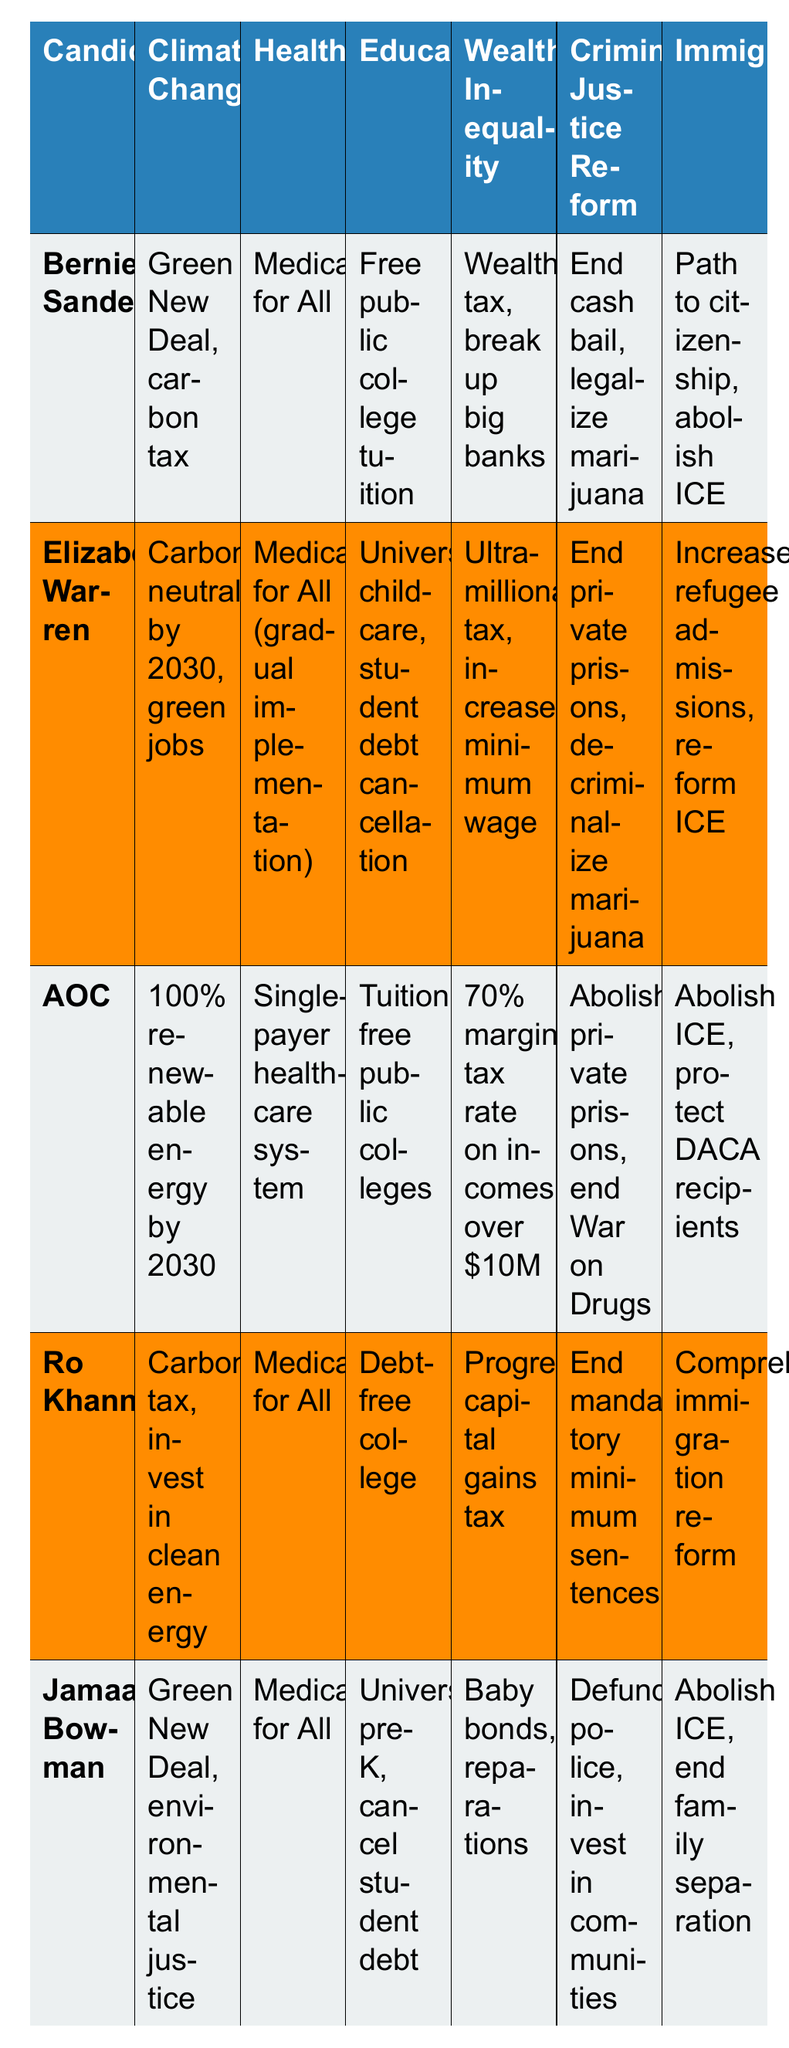What are Bernie Sanders' main stances on wealth inequality? According to the table, Bernie Sanders advocates for a wealth tax and breaking up big banks as his main positions on wealth inequality.
Answer: Wealth tax, break up big banks Which candidate advocates for a carbon-neutral environment by 2030? The table indicates that Elizabeth Warren's stance includes becoming carbon-neutral by 2030 and promoting green jobs.
Answer: Elizabeth Warren Is AOC's healthcare stance more progressive than Ro Khanna's? AOC proposes a single-payer healthcare system, which is considered a strong progressive stance, while Ro Khanna supports Medicare for All, which is also progressive but may be viewed as less comprehensive since it may not explicitly state a single-payer system.
Answer: Yes Who has proposed the most comprehensive stance on immigration? AOC and Jamaal Bowman both have strong proposals, with AOC advocating for abolishing ICE and protecting DACA recipients, while Jamaal supports abolishing ICE and ending family separation. AOC's stance might be viewed as more comprehensive due to its focus on multiple aspects of immigration reform.
Answer: AOC How many candidates support Medicare for All? By looking at the healthcare stances listed in the table, it shows that Bernie Sanders, Ro Khanna, AOC, and Jamaal Bowman all advocate for Medicare for All.
Answer: Four candidates Which candidate has the most detailed education policy, according to the table? Elizabeth Warren offers a very detailed education policy with universal childcare and student debt cancellation, which entails both early education and financial relief. In comparison, other candidates have various proposals, but Warren’s is notably comprehensive.
Answer: Elizabeth Warren What common theme is present in the criminal justice reform policies of all candidates? The common theme in the candidates’ criminal justice reform policies is a focus on reducing penalties, ending private prisons, and reforming the police, suggesting a shift toward more rehabilitative justice and less punitive measures.
Answer: Reform and decriminalization If we were to assign scores based on the presence of progressive policies, which candidate might score the highest based on their overall proposals? AOC has a comprehensive range of progressive policies across all six issues listed, addressing energy, healthcare, education, wealth inequality, criminal justice reform, and immigration. This broad proposal coverage likely suggests she would score the highest on a progressive scale.
Answer: AOC Are there candidates that have similar stances on wealth inequality, and if so, who? Both Elizabeth Warren and Jamaal Bowman propose taxes targeting ultra-wealthy individuals, with Warren suggesting an ultra-millionaire tax and Bowman proposing baby bonds and reparations, indicating a shared focus on addressing wealth inequality.
Answer: Yes, Warren and Bowman Which candidate's climate change policy includes a direct tax approach? Ro Khanna’s climate change policy includes a carbon tax, which is a direct approach to addressing climate issues.
Answer: Ro Khanna 